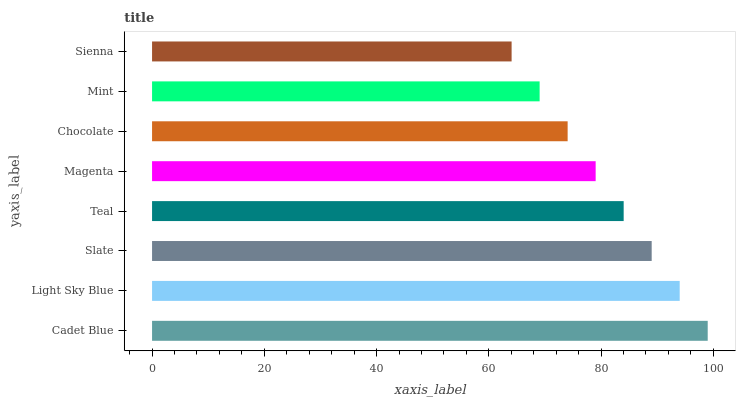Is Sienna the minimum?
Answer yes or no. Yes. Is Cadet Blue the maximum?
Answer yes or no. Yes. Is Light Sky Blue the minimum?
Answer yes or no. No. Is Light Sky Blue the maximum?
Answer yes or no. No. Is Cadet Blue greater than Light Sky Blue?
Answer yes or no. Yes. Is Light Sky Blue less than Cadet Blue?
Answer yes or no. Yes. Is Light Sky Blue greater than Cadet Blue?
Answer yes or no. No. Is Cadet Blue less than Light Sky Blue?
Answer yes or no. No. Is Teal the high median?
Answer yes or no. Yes. Is Magenta the low median?
Answer yes or no. Yes. Is Cadet Blue the high median?
Answer yes or no. No. Is Mint the low median?
Answer yes or no. No. 